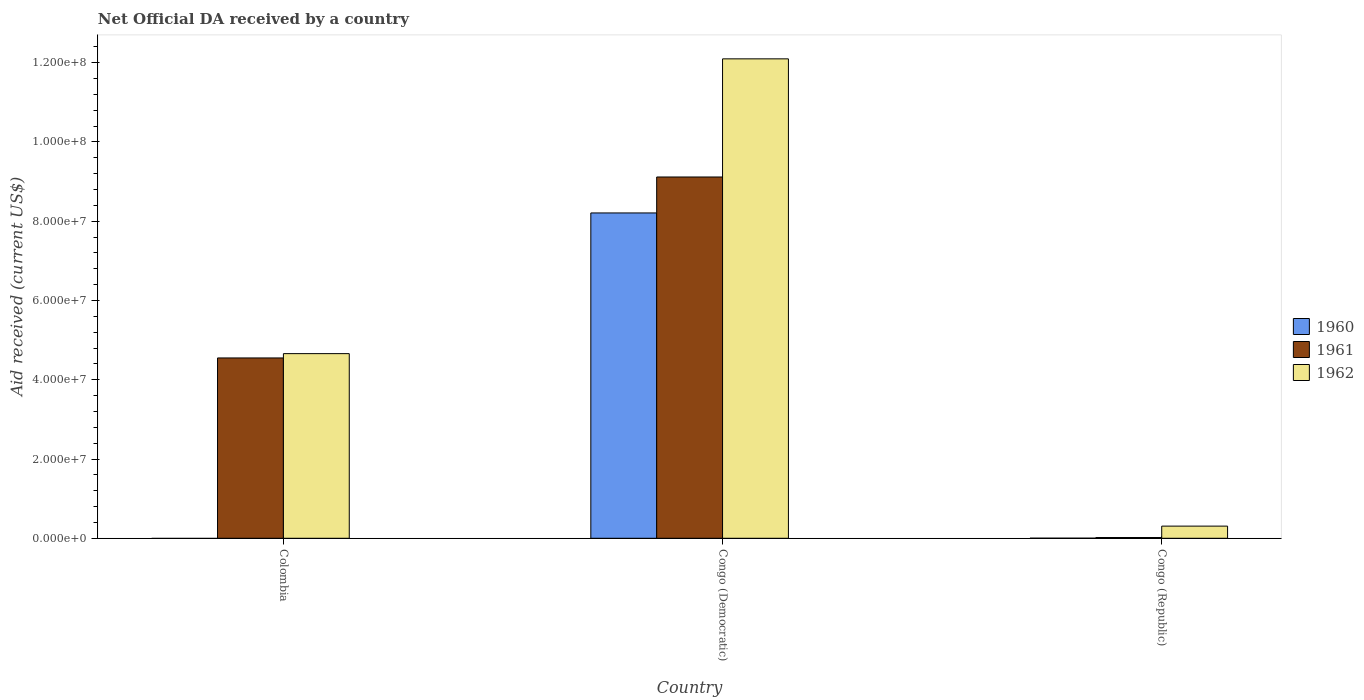How many groups of bars are there?
Give a very brief answer. 3. Are the number of bars per tick equal to the number of legend labels?
Provide a short and direct response. No. What is the label of the 2nd group of bars from the left?
Your response must be concise. Congo (Democratic). Across all countries, what is the maximum net official development assistance aid received in 1961?
Ensure brevity in your answer.  9.12e+07. Across all countries, what is the minimum net official development assistance aid received in 1961?
Keep it short and to the point. 1.90e+05. In which country was the net official development assistance aid received in 1960 maximum?
Offer a very short reply. Congo (Democratic). What is the total net official development assistance aid received in 1960 in the graph?
Keep it short and to the point. 8.21e+07. What is the difference between the net official development assistance aid received in 1962 in Congo (Democratic) and that in Congo (Republic)?
Keep it short and to the point. 1.18e+08. What is the difference between the net official development assistance aid received in 1960 in Colombia and the net official development assistance aid received in 1962 in Congo (Republic)?
Offer a terse response. -3.07e+06. What is the average net official development assistance aid received in 1960 per country?
Give a very brief answer. 2.74e+07. What is the difference between the net official development assistance aid received of/in 1961 and net official development assistance aid received of/in 1962 in Colombia?
Offer a very short reply. -1.09e+06. In how many countries, is the net official development assistance aid received in 1962 greater than 20000000 US$?
Offer a very short reply. 2. What is the ratio of the net official development assistance aid received in 1962 in Congo (Democratic) to that in Congo (Republic)?
Your response must be concise. 39.4. Is the net official development assistance aid received in 1962 in Congo (Democratic) less than that in Congo (Republic)?
Offer a terse response. No. What is the difference between the highest and the second highest net official development assistance aid received in 1962?
Ensure brevity in your answer.  1.18e+08. What is the difference between the highest and the lowest net official development assistance aid received in 1962?
Keep it short and to the point. 1.18e+08. How many bars are there?
Provide a succinct answer. 8. How many countries are there in the graph?
Keep it short and to the point. 3. Does the graph contain any zero values?
Ensure brevity in your answer.  Yes. Where does the legend appear in the graph?
Give a very brief answer. Center right. How many legend labels are there?
Offer a terse response. 3. How are the legend labels stacked?
Provide a short and direct response. Vertical. What is the title of the graph?
Your response must be concise. Net Official DA received by a country. Does "1987" appear as one of the legend labels in the graph?
Ensure brevity in your answer.  No. What is the label or title of the Y-axis?
Offer a terse response. Aid received (current US$). What is the Aid received (current US$) of 1960 in Colombia?
Give a very brief answer. 0. What is the Aid received (current US$) in 1961 in Colombia?
Keep it short and to the point. 4.55e+07. What is the Aid received (current US$) in 1962 in Colombia?
Your answer should be compact. 4.66e+07. What is the Aid received (current US$) of 1960 in Congo (Democratic)?
Provide a succinct answer. 8.21e+07. What is the Aid received (current US$) in 1961 in Congo (Democratic)?
Provide a succinct answer. 9.12e+07. What is the Aid received (current US$) in 1962 in Congo (Democratic)?
Your answer should be very brief. 1.21e+08. What is the Aid received (current US$) in 1960 in Congo (Republic)?
Provide a short and direct response. 2.00e+04. What is the Aid received (current US$) of 1962 in Congo (Republic)?
Offer a very short reply. 3.07e+06. Across all countries, what is the maximum Aid received (current US$) of 1960?
Ensure brevity in your answer.  8.21e+07. Across all countries, what is the maximum Aid received (current US$) in 1961?
Give a very brief answer. 9.12e+07. Across all countries, what is the maximum Aid received (current US$) in 1962?
Keep it short and to the point. 1.21e+08. Across all countries, what is the minimum Aid received (current US$) of 1962?
Ensure brevity in your answer.  3.07e+06. What is the total Aid received (current US$) of 1960 in the graph?
Ensure brevity in your answer.  8.21e+07. What is the total Aid received (current US$) in 1961 in the graph?
Give a very brief answer. 1.37e+08. What is the total Aid received (current US$) of 1962 in the graph?
Your response must be concise. 1.71e+08. What is the difference between the Aid received (current US$) in 1961 in Colombia and that in Congo (Democratic)?
Ensure brevity in your answer.  -4.57e+07. What is the difference between the Aid received (current US$) in 1962 in Colombia and that in Congo (Democratic)?
Your answer should be very brief. -7.44e+07. What is the difference between the Aid received (current US$) of 1961 in Colombia and that in Congo (Republic)?
Provide a succinct answer. 4.53e+07. What is the difference between the Aid received (current US$) of 1962 in Colombia and that in Congo (Republic)?
Your response must be concise. 4.35e+07. What is the difference between the Aid received (current US$) in 1960 in Congo (Democratic) and that in Congo (Republic)?
Make the answer very short. 8.21e+07. What is the difference between the Aid received (current US$) in 1961 in Congo (Democratic) and that in Congo (Republic)?
Your answer should be very brief. 9.10e+07. What is the difference between the Aid received (current US$) of 1962 in Congo (Democratic) and that in Congo (Republic)?
Make the answer very short. 1.18e+08. What is the difference between the Aid received (current US$) of 1961 in Colombia and the Aid received (current US$) of 1962 in Congo (Democratic)?
Offer a terse response. -7.55e+07. What is the difference between the Aid received (current US$) in 1961 in Colombia and the Aid received (current US$) in 1962 in Congo (Republic)?
Provide a short and direct response. 4.24e+07. What is the difference between the Aid received (current US$) in 1960 in Congo (Democratic) and the Aid received (current US$) in 1961 in Congo (Republic)?
Make the answer very short. 8.19e+07. What is the difference between the Aid received (current US$) in 1960 in Congo (Democratic) and the Aid received (current US$) in 1962 in Congo (Republic)?
Offer a very short reply. 7.90e+07. What is the difference between the Aid received (current US$) of 1961 in Congo (Democratic) and the Aid received (current US$) of 1962 in Congo (Republic)?
Ensure brevity in your answer.  8.81e+07. What is the average Aid received (current US$) in 1960 per country?
Ensure brevity in your answer.  2.74e+07. What is the average Aid received (current US$) of 1961 per country?
Give a very brief answer. 4.56e+07. What is the average Aid received (current US$) in 1962 per country?
Your answer should be compact. 5.69e+07. What is the difference between the Aid received (current US$) of 1961 and Aid received (current US$) of 1962 in Colombia?
Keep it short and to the point. -1.09e+06. What is the difference between the Aid received (current US$) in 1960 and Aid received (current US$) in 1961 in Congo (Democratic)?
Offer a very short reply. -9.07e+06. What is the difference between the Aid received (current US$) in 1960 and Aid received (current US$) in 1962 in Congo (Democratic)?
Your response must be concise. -3.89e+07. What is the difference between the Aid received (current US$) of 1961 and Aid received (current US$) of 1962 in Congo (Democratic)?
Offer a terse response. -2.98e+07. What is the difference between the Aid received (current US$) of 1960 and Aid received (current US$) of 1961 in Congo (Republic)?
Give a very brief answer. -1.70e+05. What is the difference between the Aid received (current US$) in 1960 and Aid received (current US$) in 1962 in Congo (Republic)?
Offer a terse response. -3.05e+06. What is the difference between the Aid received (current US$) in 1961 and Aid received (current US$) in 1962 in Congo (Republic)?
Make the answer very short. -2.88e+06. What is the ratio of the Aid received (current US$) of 1961 in Colombia to that in Congo (Democratic)?
Offer a very short reply. 0.5. What is the ratio of the Aid received (current US$) in 1962 in Colombia to that in Congo (Democratic)?
Your response must be concise. 0.39. What is the ratio of the Aid received (current US$) in 1961 in Colombia to that in Congo (Republic)?
Provide a succinct answer. 239.47. What is the ratio of the Aid received (current US$) of 1962 in Colombia to that in Congo (Republic)?
Provide a short and direct response. 15.18. What is the ratio of the Aid received (current US$) of 1960 in Congo (Democratic) to that in Congo (Republic)?
Your response must be concise. 4104.5. What is the ratio of the Aid received (current US$) of 1961 in Congo (Democratic) to that in Congo (Republic)?
Your response must be concise. 479.79. What is the ratio of the Aid received (current US$) of 1962 in Congo (Democratic) to that in Congo (Republic)?
Provide a short and direct response. 39.4. What is the difference between the highest and the second highest Aid received (current US$) in 1961?
Provide a short and direct response. 4.57e+07. What is the difference between the highest and the second highest Aid received (current US$) of 1962?
Give a very brief answer. 7.44e+07. What is the difference between the highest and the lowest Aid received (current US$) in 1960?
Offer a terse response. 8.21e+07. What is the difference between the highest and the lowest Aid received (current US$) in 1961?
Your answer should be compact. 9.10e+07. What is the difference between the highest and the lowest Aid received (current US$) in 1962?
Provide a short and direct response. 1.18e+08. 